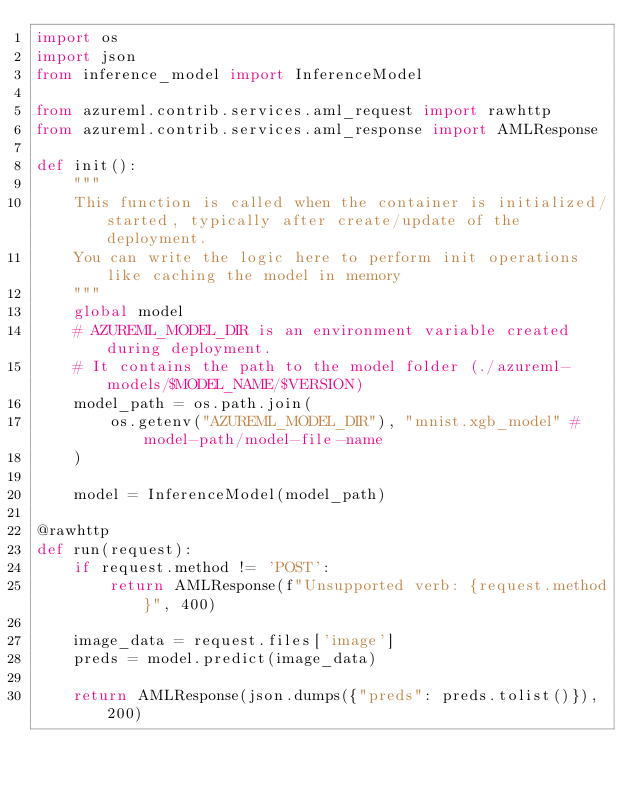Convert code to text. <code><loc_0><loc_0><loc_500><loc_500><_Python_>import os
import json
from inference_model import InferenceModel

from azureml.contrib.services.aml_request import rawhttp
from azureml.contrib.services.aml_response import AMLResponse

def init():
    """
    This function is called when the container is initialized/started, typically after create/update of the deployment.
    You can write the logic here to perform init operations like caching the model in memory
    """
    global model
    # AZUREML_MODEL_DIR is an environment variable created during deployment.
    # It contains the path to the model folder (./azureml-models/$MODEL_NAME/$VERSION)
    model_path = os.path.join(
        os.getenv("AZUREML_MODEL_DIR"), "mnist.xgb_model" # model-path/model-file-name
    )

    model = InferenceModel(model_path)

@rawhttp
def run(request):
    if request.method != 'POST':
        return AMLResponse(f"Unsupported verb: {request.method}", 400)

    image_data = request.files['image']
    preds = model.predict(image_data)
    
    return AMLResponse(json.dumps({"preds": preds.tolist()}), 200)
    </code> 